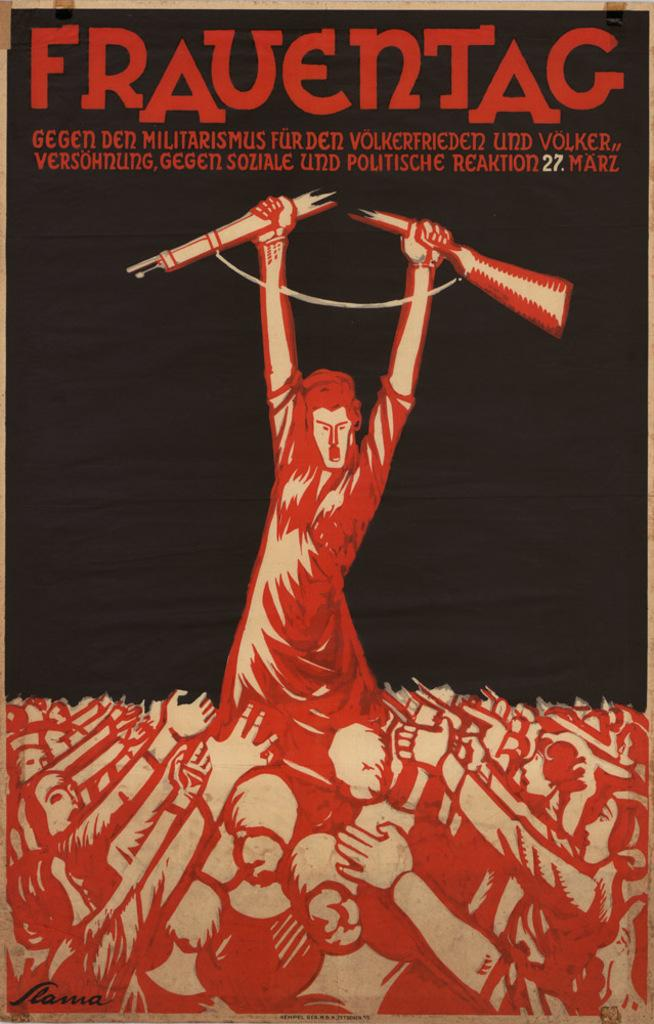<image>
Create a compact narrative representing the image presented. A poster of a women in a crowd holding a broken gun over her head with the word "Frauentag" at the top. 